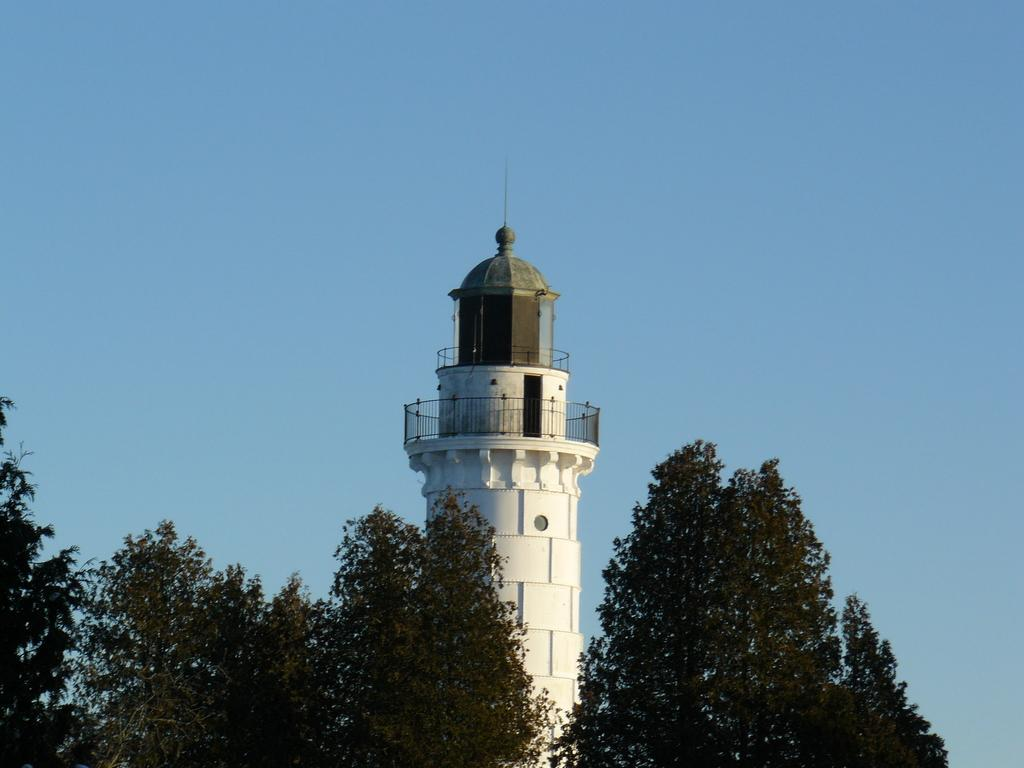What type of vegetation is at the bottom of the image? There are trees at the bottom of the image. What structure is located in the center of the image? There is a tower in the center of the image. What feature can be seen at the top of the tower? The tower has a railing at the top. What is visible at the top of the image? The sky is visible at the top of the image. What type of advice is being given at the church in the image? There is no church or advice present in the image; it features a tower with trees at the bottom and a railing at the top. What color is the vest worn by the person in the image? There is no person or vest present in the image. 